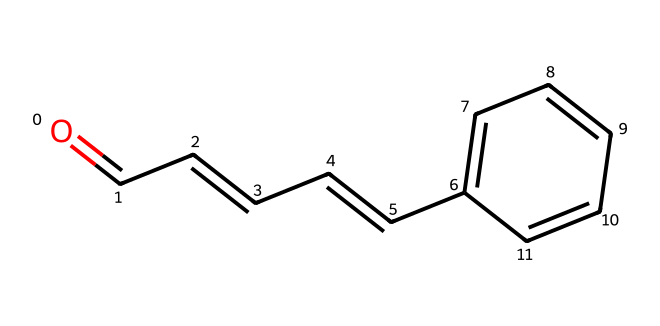What is the molecular formula of cinnamaldehyde? The SMILES representation indicates the presence of carbon (C) and hydrogen (H) atoms. By counting the number of carbon and hydrogen atoms: there are 9 carbon atoms and 8 hydrogen atoms, along with one oxygen atom. Thus, the molecular formula is C9H8O.
Answer: C9H8O How many double bonds are present in cinnamaldehyde? In the SMILES representation, the double bonds can be identified in the sections O=CC and CC=C. Counting these, there are a total of 2 double bonds.
Answer: 2 Which functional group is present in cinnamaldehyde? The presence of the carbonyl group (C=O) at the beginning of the SMILES indicates that it belongs to the aldehyde functional group.
Answer: aldehyde What is the total number of rings in the structure of cinnamaldehyde? The examination of the structure reveals that there are no rings present since all carbon and hydrogen atoms are arranged in a linear and branched manner without closed loops.
Answer: 0 Explain the significance of the carbon-carbon double bond in cinnamaldehyde's reactivity. The carbon-carbon double bond (C=C) in the structure creates areas of electron density that can undergo addition reactions, making cinnamaldehyde more reactive than alkanes, which only have single bonds. This characteristic is crucial for its chemical behavior and interactions.
Answer: reactivity What indicates that cinnamaldehyde is a plant-derived compound? The presence of the aromatic ring (indicated by ‘c’ in the SMILES) suggests that it's derived from natural plant sources since aromatic compounds are commonly found in plant metabolites.
Answer: aromatic ring 